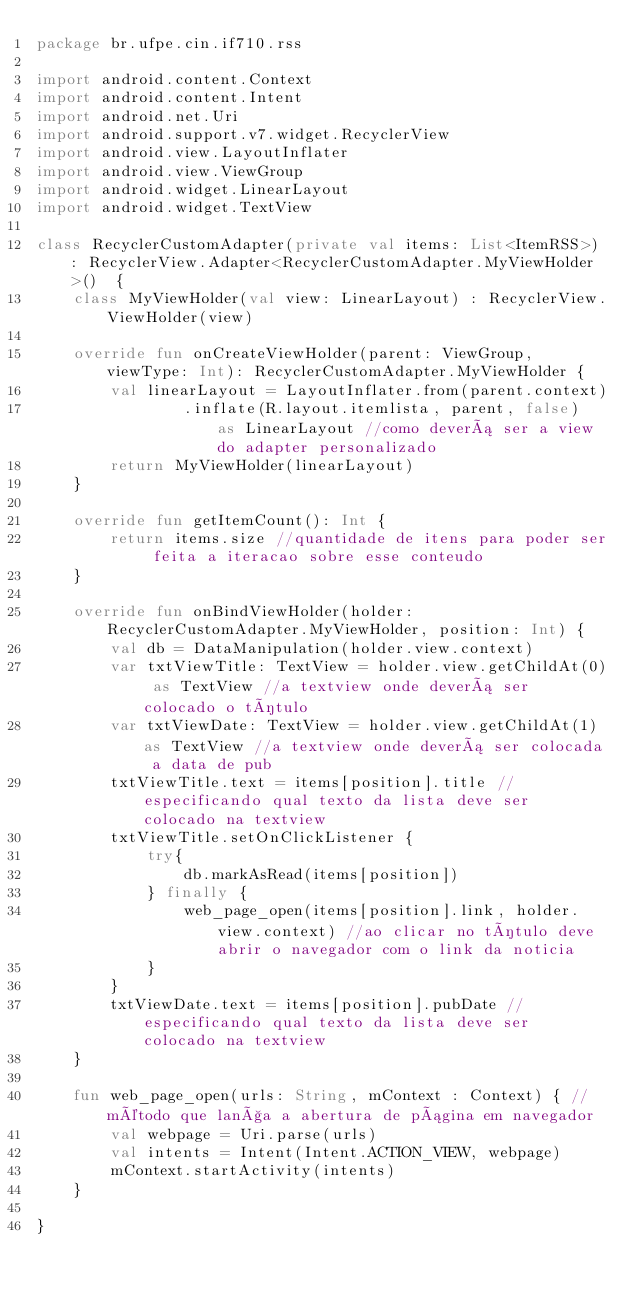Convert code to text. <code><loc_0><loc_0><loc_500><loc_500><_Kotlin_>package br.ufpe.cin.if710.rss

import android.content.Context
import android.content.Intent
import android.net.Uri
import android.support.v7.widget.RecyclerView
import android.view.LayoutInflater
import android.view.ViewGroup
import android.widget.LinearLayout
import android.widget.TextView

class RecyclerCustomAdapter(private val items: List<ItemRSS>) : RecyclerView.Adapter<RecyclerCustomAdapter.MyViewHolder>()  {
    class MyViewHolder(val view: LinearLayout) : RecyclerView.ViewHolder(view)

    override fun onCreateViewHolder(parent: ViewGroup, viewType: Int): RecyclerCustomAdapter.MyViewHolder {
        val linearLayout = LayoutInflater.from(parent.context)
                .inflate(R.layout.itemlista, parent, false)  as LinearLayout //como deverá ser a view do adapter personalizado
        return MyViewHolder(linearLayout)
    }

    override fun getItemCount(): Int {
        return items.size //quantidade de itens para poder ser feita a iteracao sobre esse conteudo
    }

    override fun onBindViewHolder(holder: RecyclerCustomAdapter.MyViewHolder, position: Int) {
        val db = DataManipulation(holder.view.context)
        var txtViewTitle: TextView = holder.view.getChildAt(0) as TextView //a textview onde deverá ser colocado o título
        var txtViewDate: TextView = holder.view.getChildAt(1) as TextView //a textview onde deverá ser colocada a data de pub
        txtViewTitle.text = items[position].title //especificando qual texto da lista deve ser colocado na textview
        txtViewTitle.setOnClickListener {
            try{
                db.markAsRead(items[position])
            } finally {
                web_page_open(items[position].link, holder.view.context) //ao clicar no título deve abrir o navegador com o link da noticia
            }
        }
        txtViewDate.text = items[position].pubDate //especificando qual texto da lista deve ser colocado na textview
    }

    fun web_page_open(urls: String, mContext : Context) { //método que lança a abertura de página em navegador
        val webpage = Uri.parse(urls)
        val intents = Intent(Intent.ACTION_VIEW, webpage)
        mContext.startActivity(intents)
    }

}

</code> 